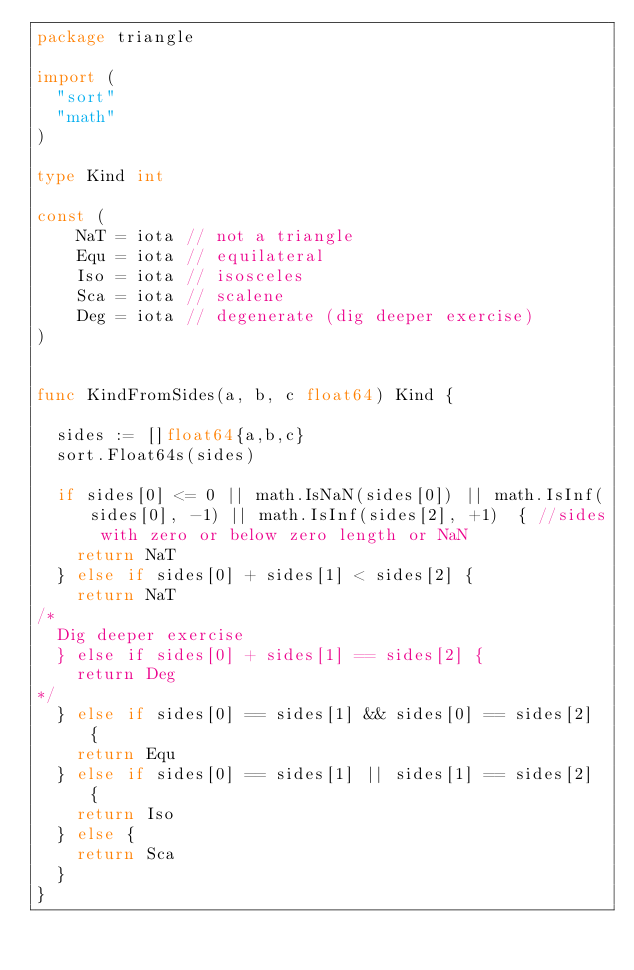Convert code to text. <code><loc_0><loc_0><loc_500><loc_500><_Go_>package triangle

import (
	"sort"
	"math"
)

type Kind int

const (
    NaT = iota // not a triangle
    Equ = iota // equilateral
    Iso = iota // isosceles
    Sca = iota // scalene
    Deg = iota // degenerate (dig deeper exercise)
)


func KindFromSides(a, b, c float64) Kind {

	sides := []float64{a,b,c}
	sort.Float64s(sides)

	if sides[0] <= 0 || math.IsNaN(sides[0]) || math.IsInf(sides[0], -1) || math.IsInf(sides[2], +1)  { //sides with zero or below zero length or NaN
		return NaT
	} else if sides[0] + sides[1] < sides[2] {
		return NaT
/*
	Dig deeper exercise
	} else if sides[0] + sides[1] == sides[2] {
		return Deg
*/
	} else if sides[0] == sides[1] && sides[0] == sides[2] {
		return Equ
	} else if sides[0] == sides[1] || sides[1] == sides[2] {
		return Iso
	} else {
		return Sca
	}
}
</code> 